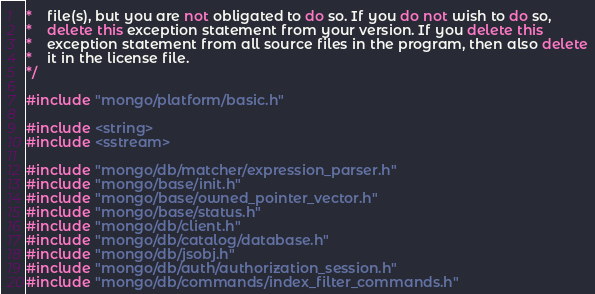<code> <loc_0><loc_0><loc_500><loc_500><_C++_>*    file(s), but you are not obligated to do so. If you do not wish to do so,
*    delete this exception statement from your version. If you delete this
*    exception statement from all source files in the program, then also delete
*    it in the license file.
*/

#include "mongo/platform/basic.h"

#include <string>
#include <sstream>

#include "mongo/db/matcher/expression_parser.h"
#include "mongo/base/init.h"
#include "mongo/base/owned_pointer_vector.h"
#include "mongo/base/status.h"
#include "mongo/db/client.h"
#include "mongo/db/catalog/database.h"
#include "mongo/db/jsobj.h"
#include "mongo/db/auth/authorization_session.h"
#include "mongo/db/commands/index_filter_commands.h"</code> 